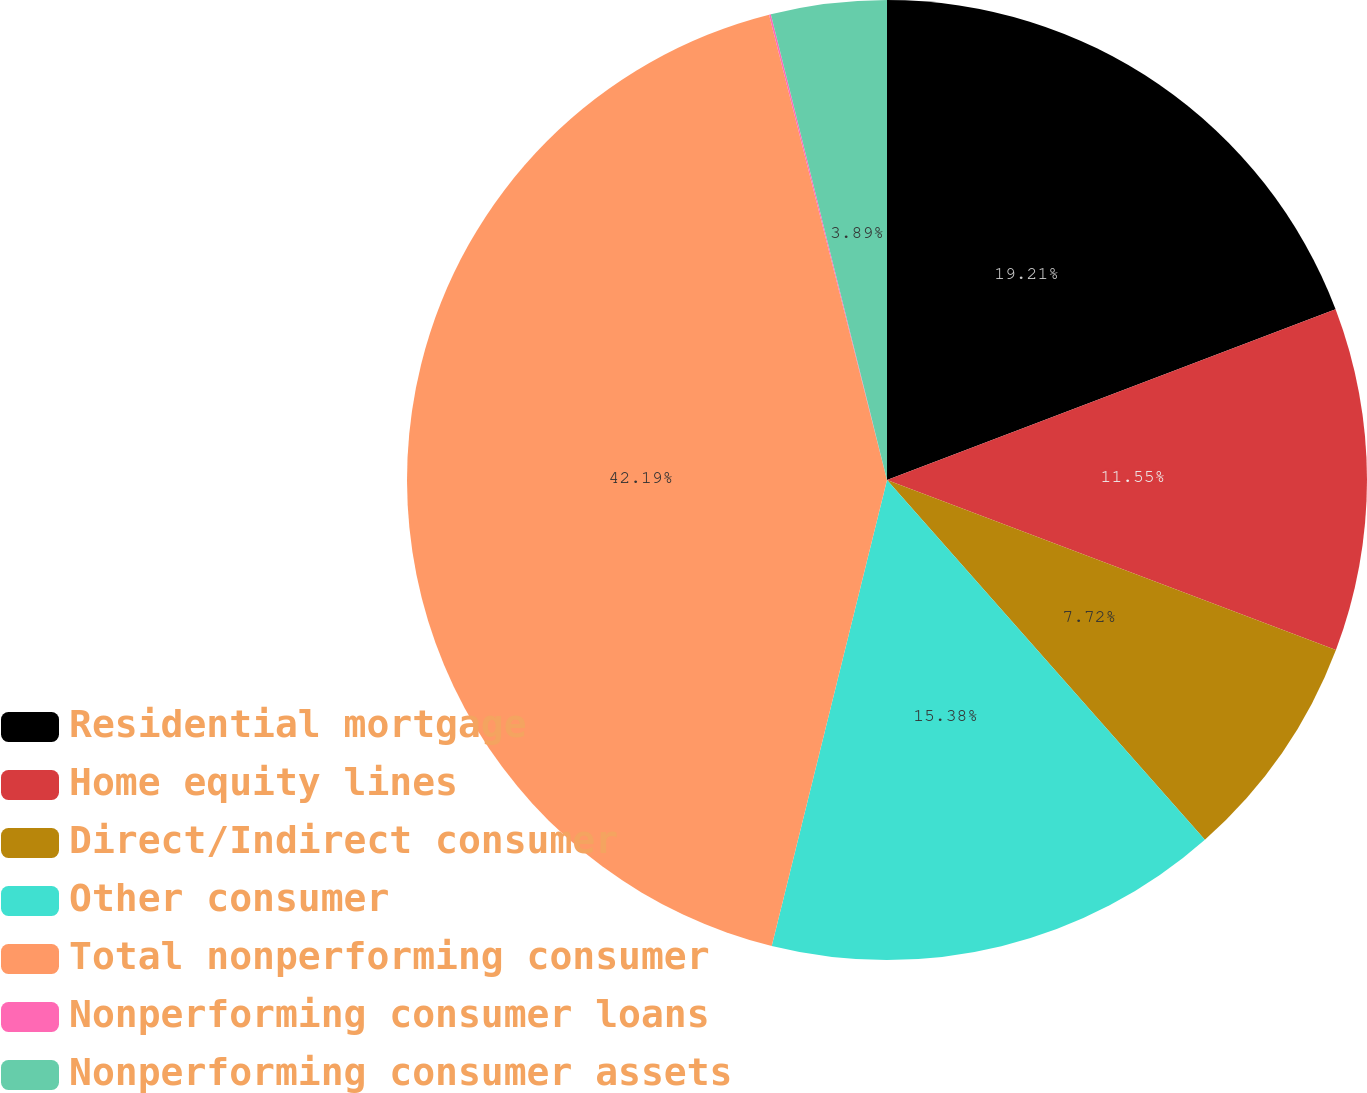Convert chart to OTSL. <chart><loc_0><loc_0><loc_500><loc_500><pie_chart><fcel>Residential mortgage<fcel>Home equity lines<fcel>Direct/Indirect consumer<fcel>Other consumer<fcel>Total nonperforming consumer<fcel>Nonperforming consumer loans<fcel>Nonperforming consumer assets<nl><fcel>19.21%<fcel>11.55%<fcel>7.72%<fcel>15.38%<fcel>42.19%<fcel>0.06%<fcel>3.89%<nl></chart> 